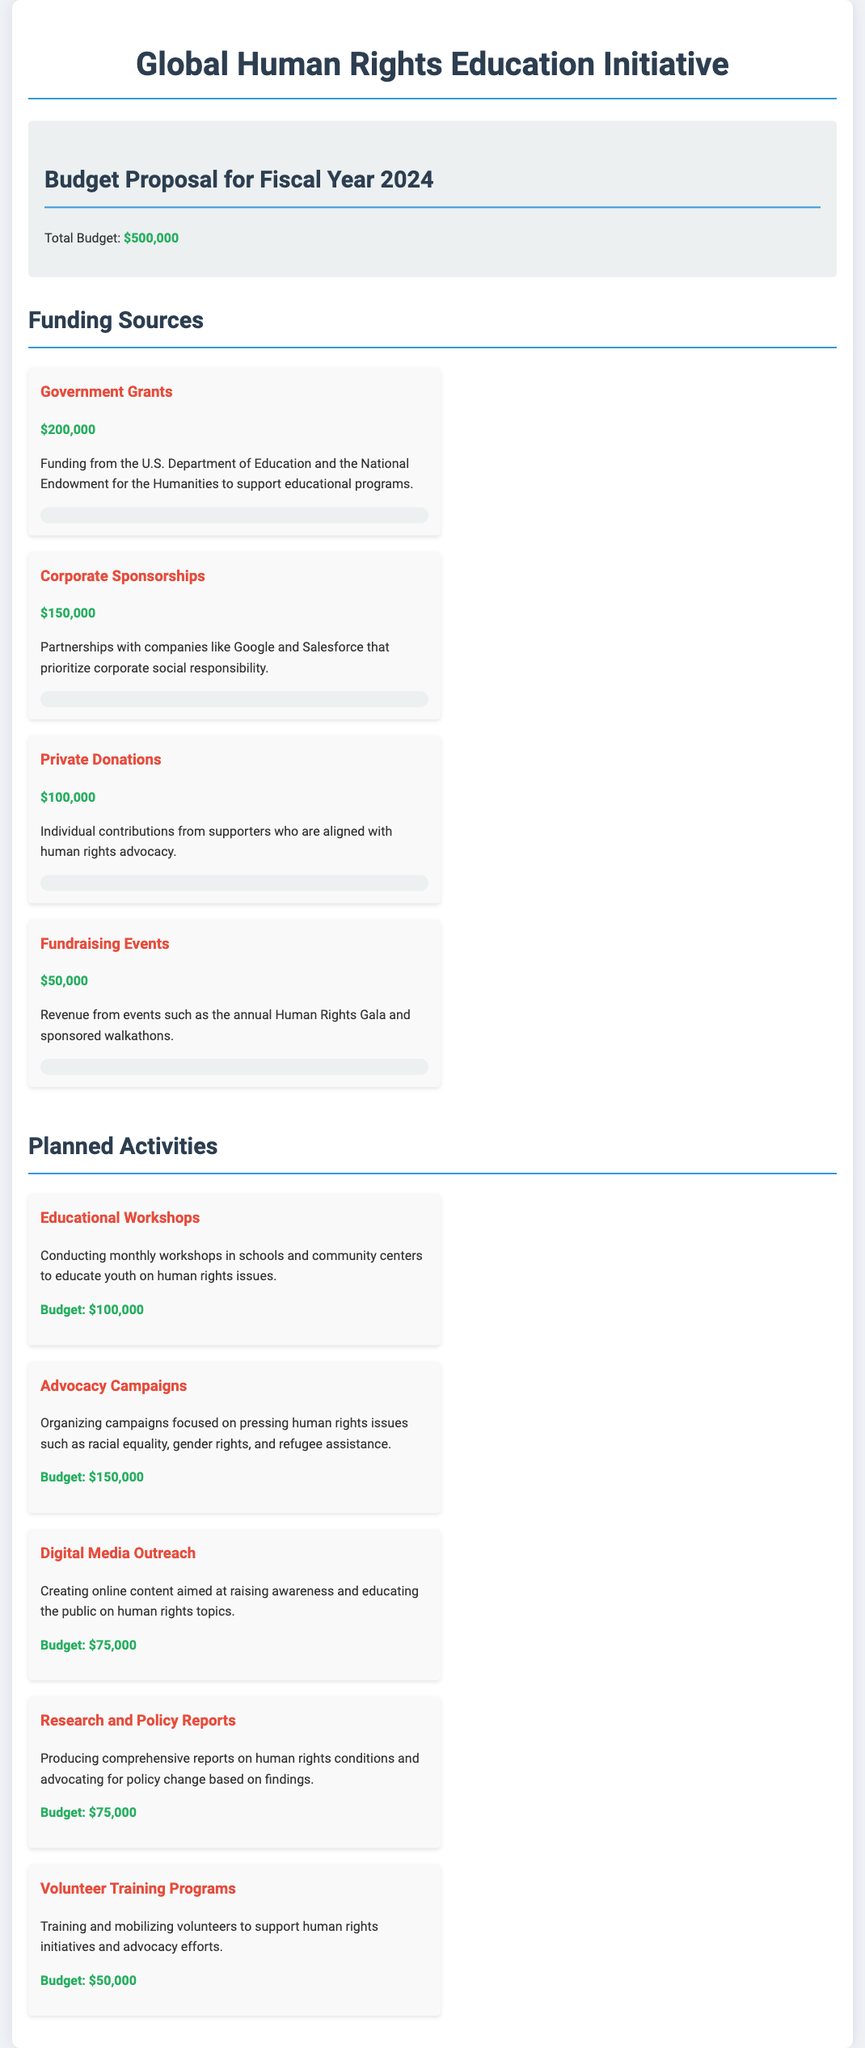What is the total budget for the fiscal year 2024? The total budget is clearly stated in the budget summary section of the document.
Answer: $500,000 How much funding comes from government grants? The document specifies the amount allocated from government grants under the funding sources section.
Answer: $200,000 What is the budget allocated for advocacy campaigns? The planned activities section lists the budget for advocacy campaigns, which is a specific activity outlined.
Answer: $150,000 Which company is mentioned as a corporate sponsor? The funding sources section mentions partnerships with specific companies.
Answer: Google What is the budget for volunteer training programs? The amount allocated for volunteer training programs can be found under planned activities in the document.
Answer: $50,000 How much revenue is expected from fundraising events? The document includes information regarding revenue from fundraising events in the funding sources section.
Answer: $50,000 What percentage of the funding from private donations has been secured? The document provides the percentage secured next to each funding source, specifically for private donations.
Answer: 20% What is the primary focus of the educational workshops? The details in the planned activities section describe the main objective of the workshops.
Answer: Human rights issues How many planned activities are listed in the document? By counting the activities in the planned activities section, the total can be easily determined.
Answer: 5 